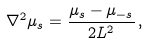<formula> <loc_0><loc_0><loc_500><loc_500>\nabla ^ { 2 } \mu _ { s } = \frac { \mu _ { s } - \mu _ { - s } } { 2 L ^ { 2 } } \, ,</formula> 